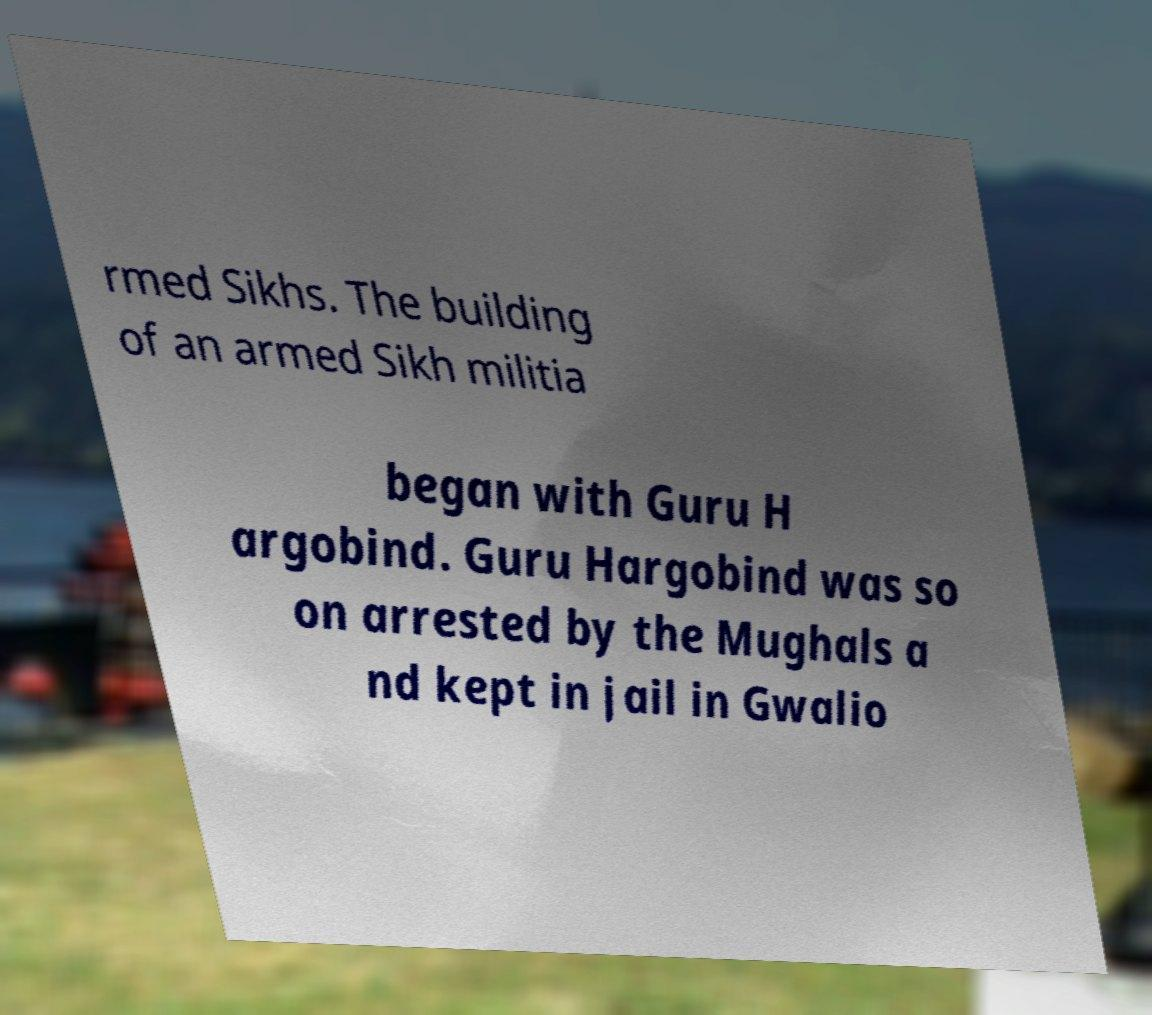Can you read and provide the text displayed in the image?This photo seems to have some interesting text. Can you extract and type it out for me? rmed Sikhs. The building of an armed Sikh militia began with Guru H argobind. Guru Hargobind was so on arrested by the Mughals a nd kept in jail in Gwalio 